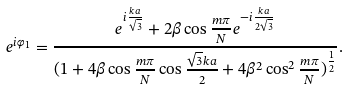<formula> <loc_0><loc_0><loc_500><loc_500>e ^ { i \varphi _ { 1 } } = \frac { e ^ { i \frac { k a } { \sqrt { 3 } } } + 2 \beta \cos \frac { m \pi } { N } e ^ { - i \frac { k a } { 2 \sqrt { 3 } } } } { ( 1 + 4 \beta \cos \frac { m \pi } { N } \cos \frac { \sqrt { 3 } k a } { 2 } + 4 \beta ^ { 2 } \cos ^ { 2 } \frac { m \pi } { N } ) ^ { \frac { 1 } { 2 } } } .</formula> 